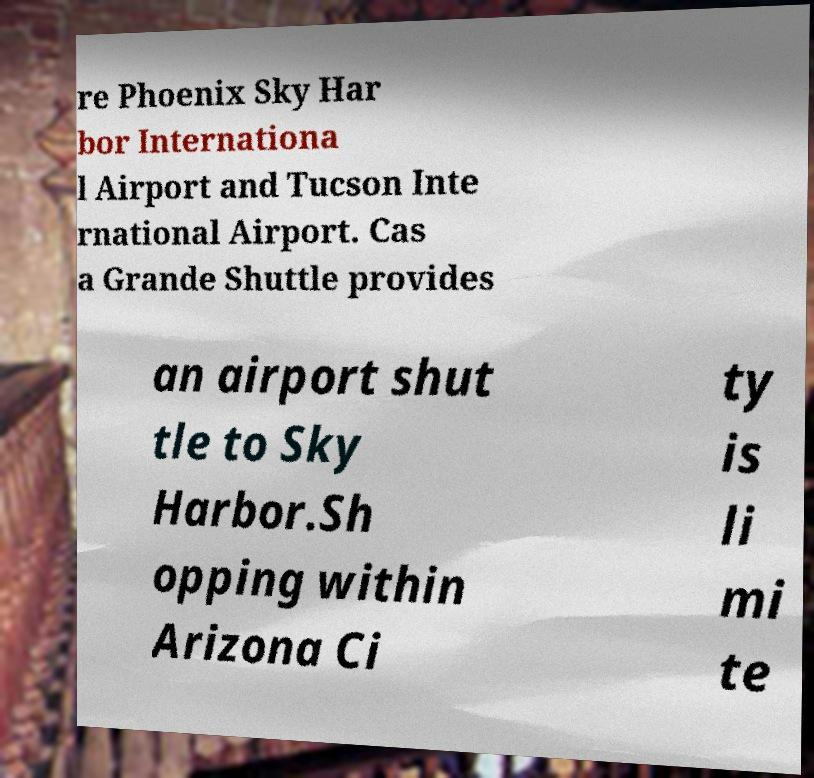What messages or text are displayed in this image? I need them in a readable, typed format. re Phoenix Sky Har bor Internationa l Airport and Tucson Inte rnational Airport. Cas a Grande Shuttle provides an airport shut tle to Sky Harbor.Sh opping within Arizona Ci ty is li mi te 